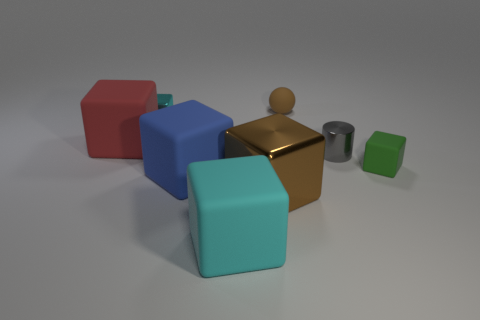Add 1 tiny metal cylinders. How many objects exist? 9 Subtract all shiny blocks. How many blocks are left? 4 Subtract all purple cylinders. How many cyan blocks are left? 2 Subtract 1 balls. How many balls are left? 0 Subtract all spheres. How many objects are left? 7 Subtract all red blocks. How many blocks are left? 5 Add 3 big blocks. How many big blocks exist? 7 Subtract 0 yellow cubes. How many objects are left? 8 Subtract all red cylinders. Subtract all brown balls. How many cylinders are left? 1 Subtract all tiny green blocks. Subtract all tiny green matte blocks. How many objects are left? 6 